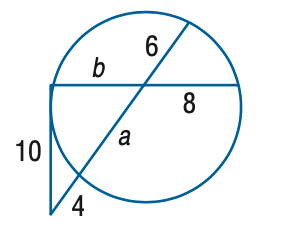Answer the mathemtical geometry problem and directly provide the correct option letter.
Question: Find the variable of b to the nearest tenth. Assume that segments that appear to be tangent are tangent.
Choices: A: 11.3 B: 11.8 C: 12.3 D: 12.8 A 